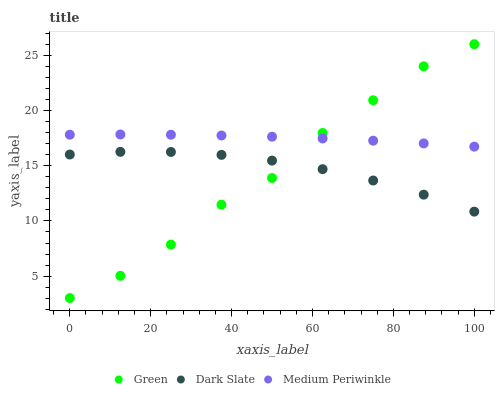Does Green have the minimum area under the curve?
Answer yes or no. Yes. Does Medium Periwinkle have the maximum area under the curve?
Answer yes or no. Yes. Does Medium Periwinkle have the minimum area under the curve?
Answer yes or no. No. Does Green have the maximum area under the curve?
Answer yes or no. No. Is Medium Periwinkle the smoothest?
Answer yes or no. Yes. Is Green the roughest?
Answer yes or no. Yes. Is Green the smoothest?
Answer yes or no. No. Is Medium Periwinkle the roughest?
Answer yes or no. No. Does Green have the lowest value?
Answer yes or no. Yes. Does Medium Periwinkle have the lowest value?
Answer yes or no. No. Does Green have the highest value?
Answer yes or no. Yes. Does Medium Periwinkle have the highest value?
Answer yes or no. No. Is Dark Slate less than Medium Periwinkle?
Answer yes or no. Yes. Is Medium Periwinkle greater than Dark Slate?
Answer yes or no. Yes. Does Green intersect Medium Periwinkle?
Answer yes or no. Yes. Is Green less than Medium Periwinkle?
Answer yes or no. No. Is Green greater than Medium Periwinkle?
Answer yes or no. No. Does Dark Slate intersect Medium Periwinkle?
Answer yes or no. No. 